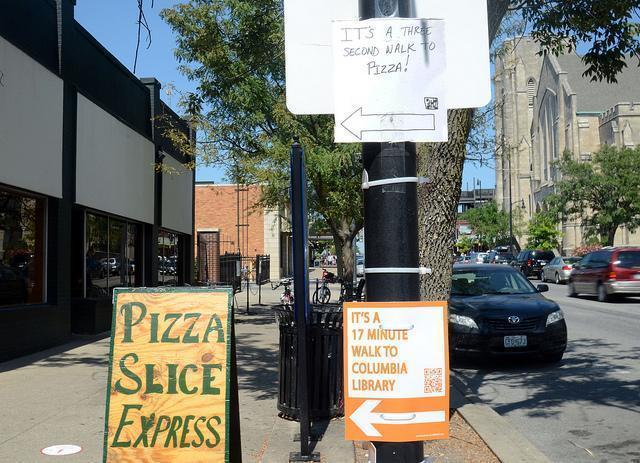What is the building across the street from the orange sign used for?
Answer the question by selecting the correct answer among the 4 following choices.
Options: Education, business, religious services, government office. Religious services. 